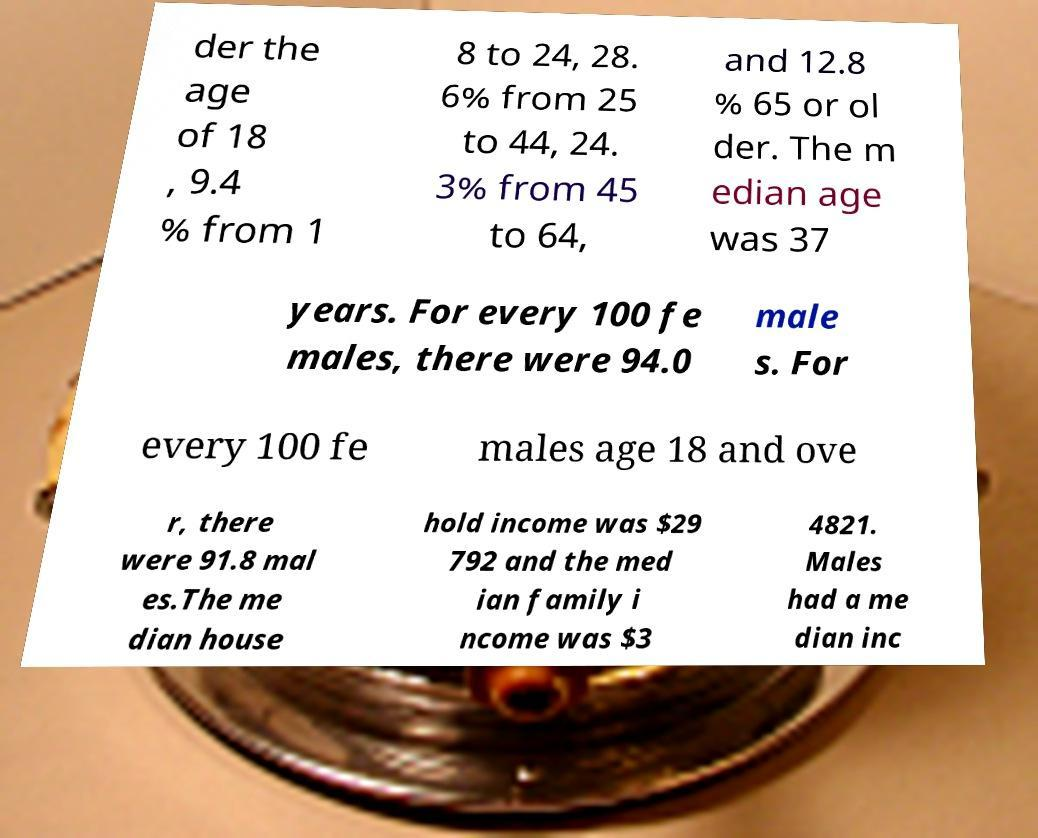There's text embedded in this image that I need extracted. Can you transcribe it verbatim? der the age of 18 , 9.4 % from 1 8 to 24, 28. 6% from 25 to 44, 24. 3% from 45 to 64, and 12.8 % 65 or ol der. The m edian age was 37 years. For every 100 fe males, there were 94.0 male s. For every 100 fe males age 18 and ove r, there were 91.8 mal es.The me dian house hold income was $29 792 and the med ian family i ncome was $3 4821. Males had a me dian inc 